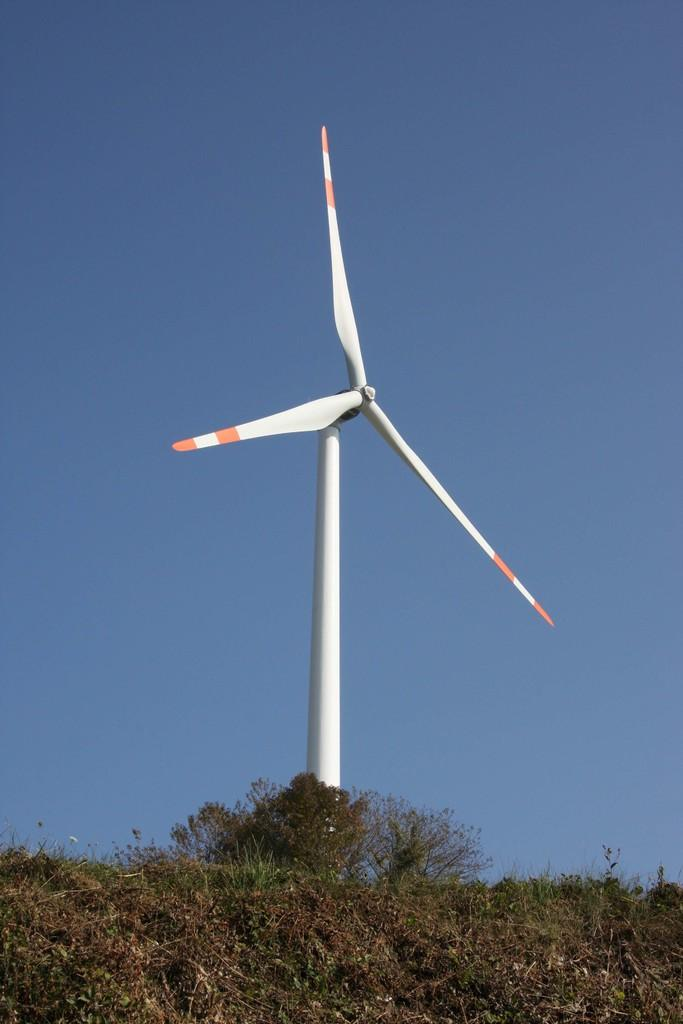Where was the picture taken? The picture was clicked outside. What is the main subject in the center of the image? There is a white color windmill in the center of the image. What can be seen in the foreground of the image? In the foreground, there are plants and grass. What is visible in the background of the image? The sky is visible in the background of the image. Can you see a cap on the windmill in the image? There is no cap visible on the windmill in the image. Is there a window in the image? There is no window present in the image. 